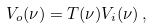Convert formula to latex. <formula><loc_0><loc_0><loc_500><loc_500>V _ { o } ( \nu ) = T ( \nu ) V _ { i } ( \nu ) \, ,</formula> 